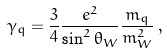<formula> <loc_0><loc_0><loc_500><loc_500>\gamma _ { q } = \frac { 3 } { 4 } \frac { e ^ { 2 } } { \sin ^ { 2 } \theta _ { W } } \frac { m _ { q } } { m _ { W } ^ { 2 } } \, ,</formula> 